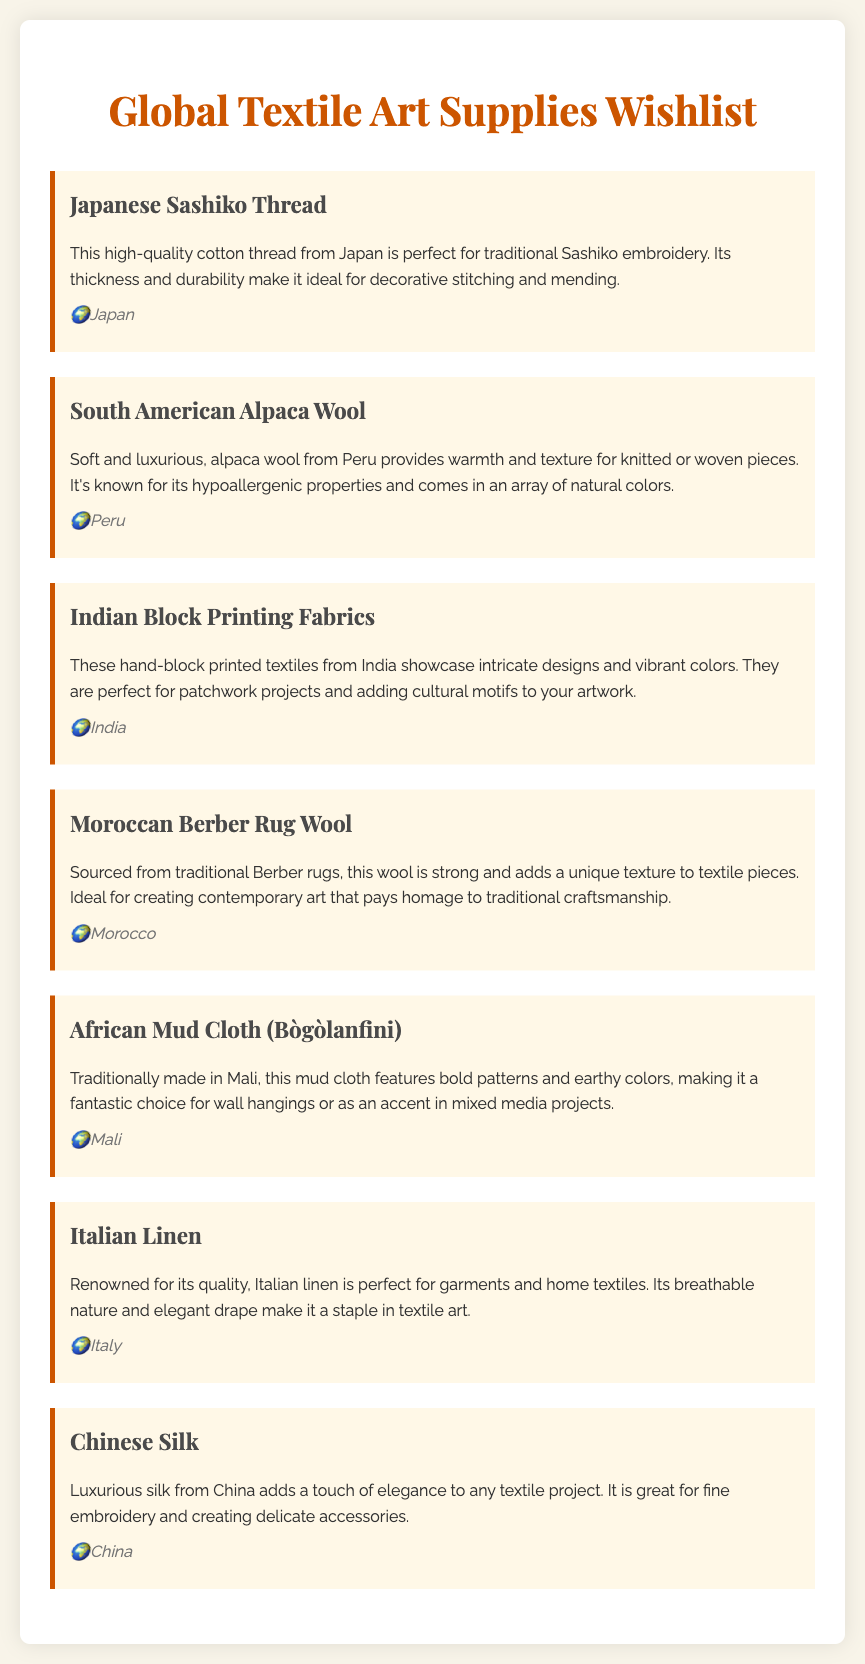What is the title of the document? The title is prominently displayed at the top of the document, indicating the subject matter related to textile art supplies.
Answer: Global Textile Art Supplies Wishlist Which country is the Japanese Sashiko Thread sourced from? The document specifies the origin of the Sashiko thread clearly in the source section of that item.
Answer: Japan What type of fabric is known for being hypoallergenic? The document features a description of alpaca wool that highlights its hypoallergenic properties as a key characteristic.
Answer: Alpaca Wool What fabric is used for traditional Sashiko embroidery? The document explicitly states which material is ideal for Sashiko embroidery in its description.
Answer: Japanese Sashiko Thread Which country produces the African Mud Cloth? A specific item lists the country of origin for the African Mud Cloth, providing clear attribution to its cultural roots.
Answer: Mali What is the main quality of Italian Linen mentioned? The document highlights the breathability and drape of Italian linen in its description, which are key qualities of the fabric.
Answer: Breathable nature How does the Moroccan Berber Rug Wool contribute to textile pieces? The description of Moroccan wool emphasizes its strong nature and unique texture as important contributions.
Answer: Unique texture What type of textile is characterized by bold patterns? The document describes a particular fabric that includes bold patterns, clearly identifying its visual feature.
Answer: African Mud Cloth What is Chinese Silk commonly used for in textile projects? The document outlines the primary application of Chinese silk, emphasizing its use in detailed textile projects.
Answer: Fine embroidery 